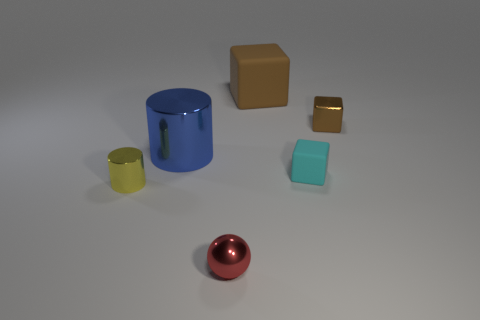Add 1 yellow cubes. How many objects exist? 7 Subtract all balls. How many objects are left? 5 Subtract all tiny yellow cylinders. Subtract all small metallic cylinders. How many objects are left? 4 Add 1 small brown objects. How many small brown objects are left? 2 Add 2 blocks. How many blocks exist? 5 Subtract 0 green balls. How many objects are left? 6 